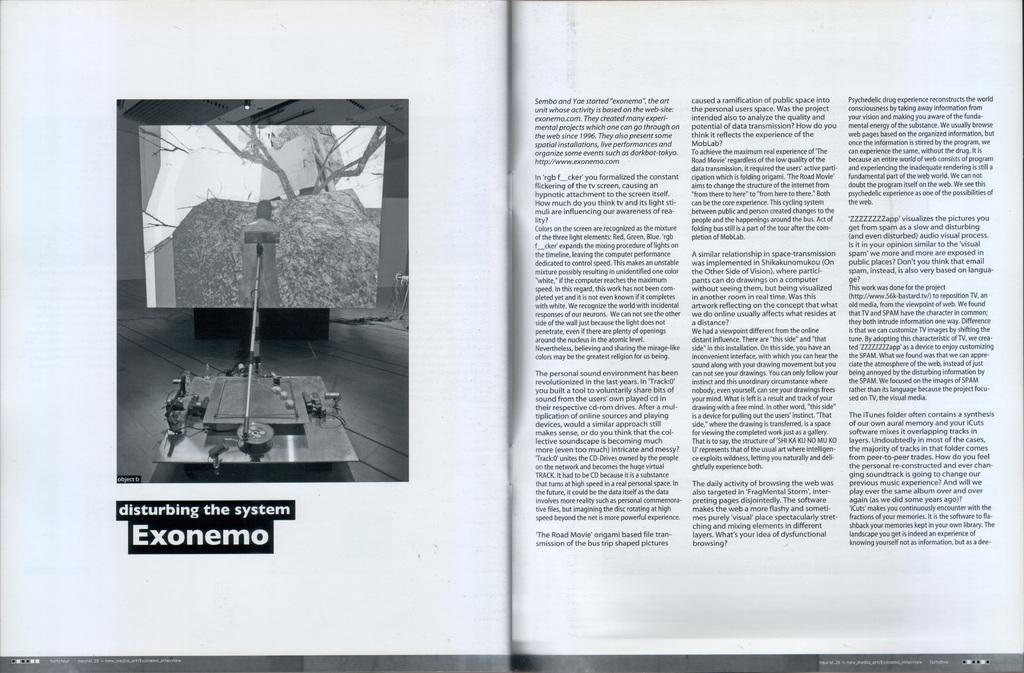How would you summarize this image in a sentence or two? In this picture we can see a page,in this page we can see some text. 